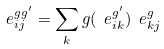<formula> <loc_0><loc_0><loc_500><loc_500>\ e ^ { g g ^ { \prime } } _ { i j } = \sum _ { k } g ( \ e ^ { g ^ { \prime } } _ { i k } ) \ e ^ { g } _ { k j }</formula> 